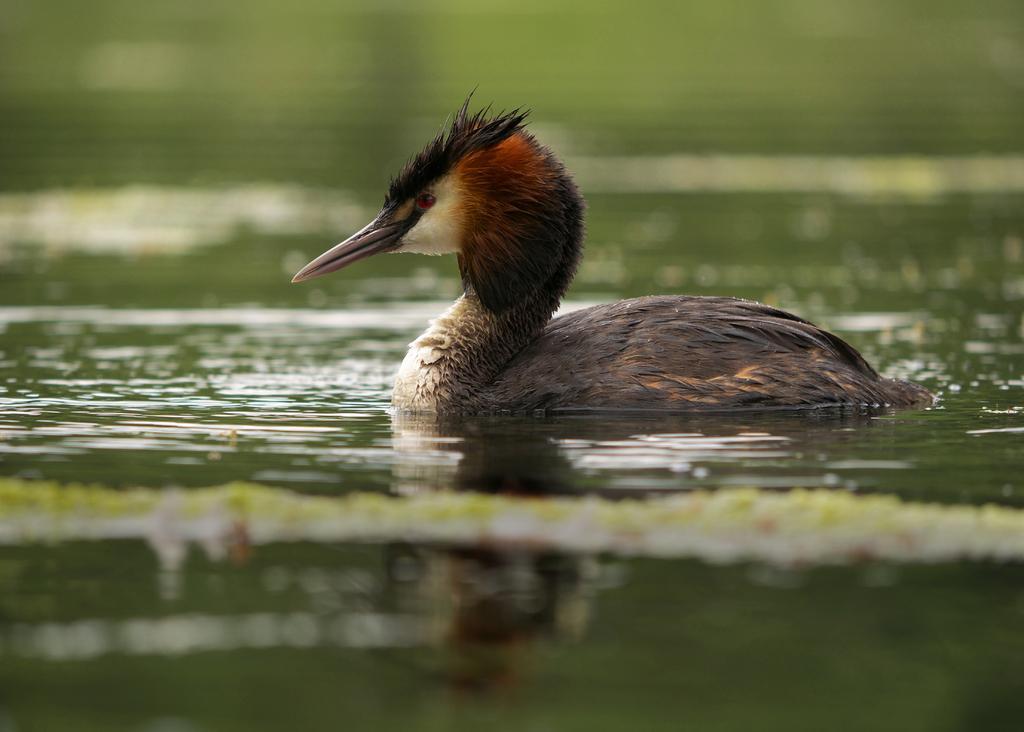Could you give a brief overview of what you see in this image? In this image I can see water and on the water I can see a brown colour bird. 